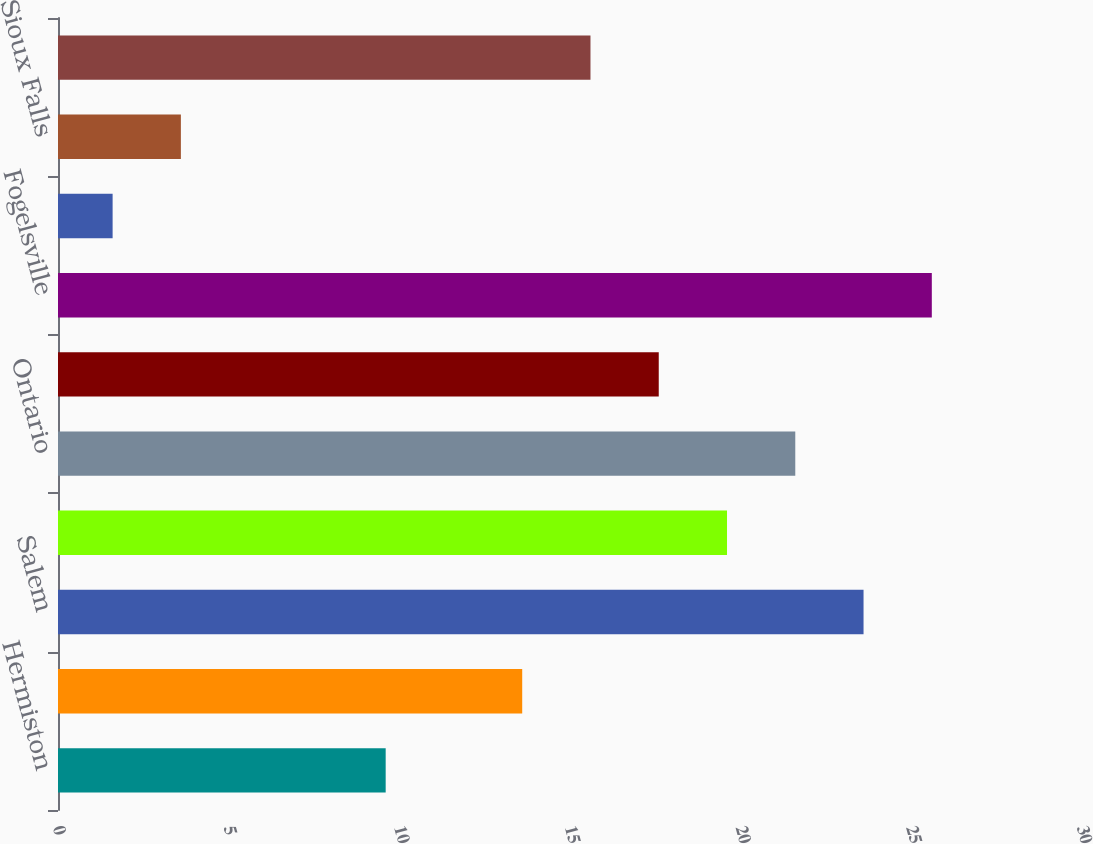Convert chart. <chart><loc_0><loc_0><loc_500><loc_500><bar_chart><fcel>Hermiston<fcel>Milwaukee<fcel>Salem<fcel>Woodburn<fcel>Ontario<fcel>Leesport<fcel>Fogelsville<fcel>Columbia<fcel>Sioux Falls<fcel>Memphis<nl><fcel>9.6<fcel>13.6<fcel>23.6<fcel>19.6<fcel>21.6<fcel>17.6<fcel>25.6<fcel>1.6<fcel>3.6<fcel>15.6<nl></chart> 